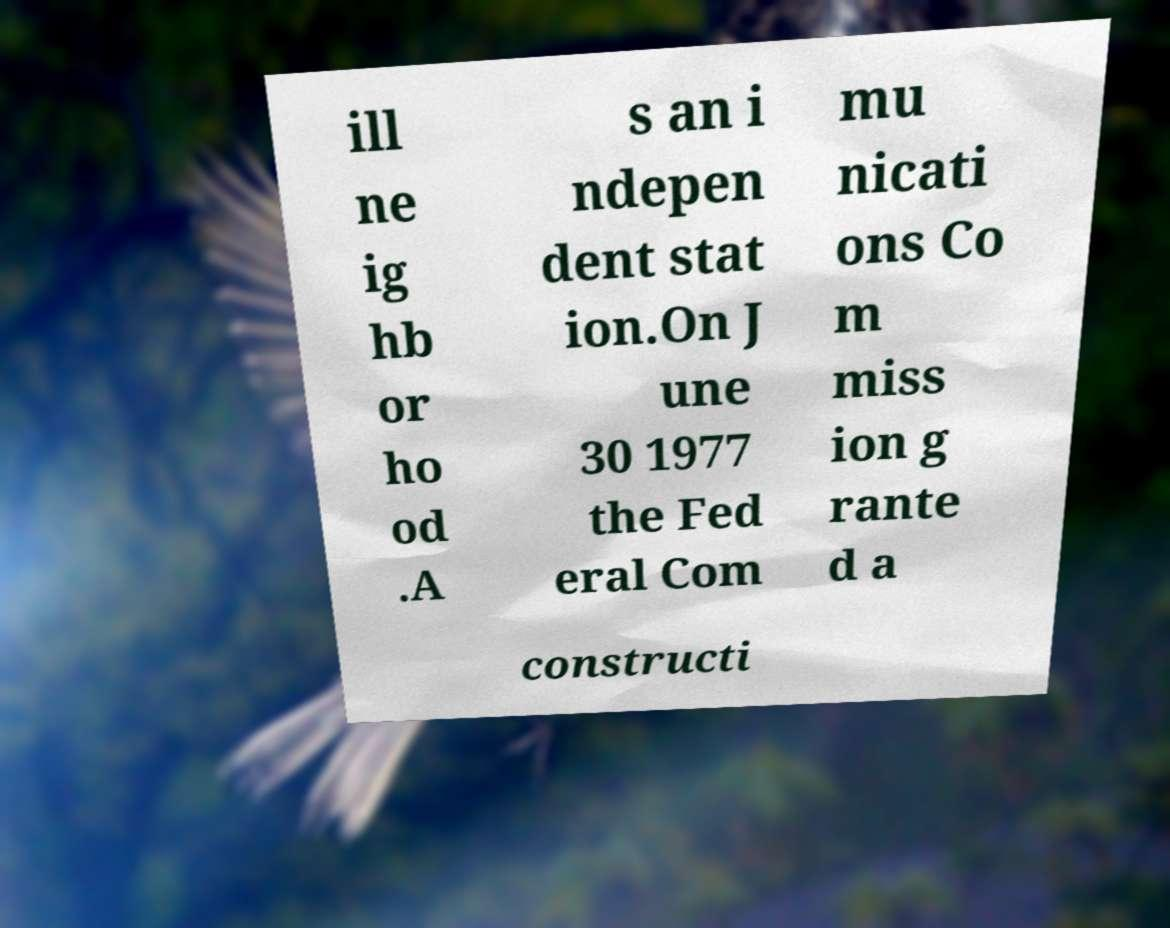Please read and relay the text visible in this image. What does it say? ill ne ig hb or ho od .A s an i ndepen dent stat ion.On J une 30 1977 the Fed eral Com mu nicati ons Co m miss ion g rante d a constructi 